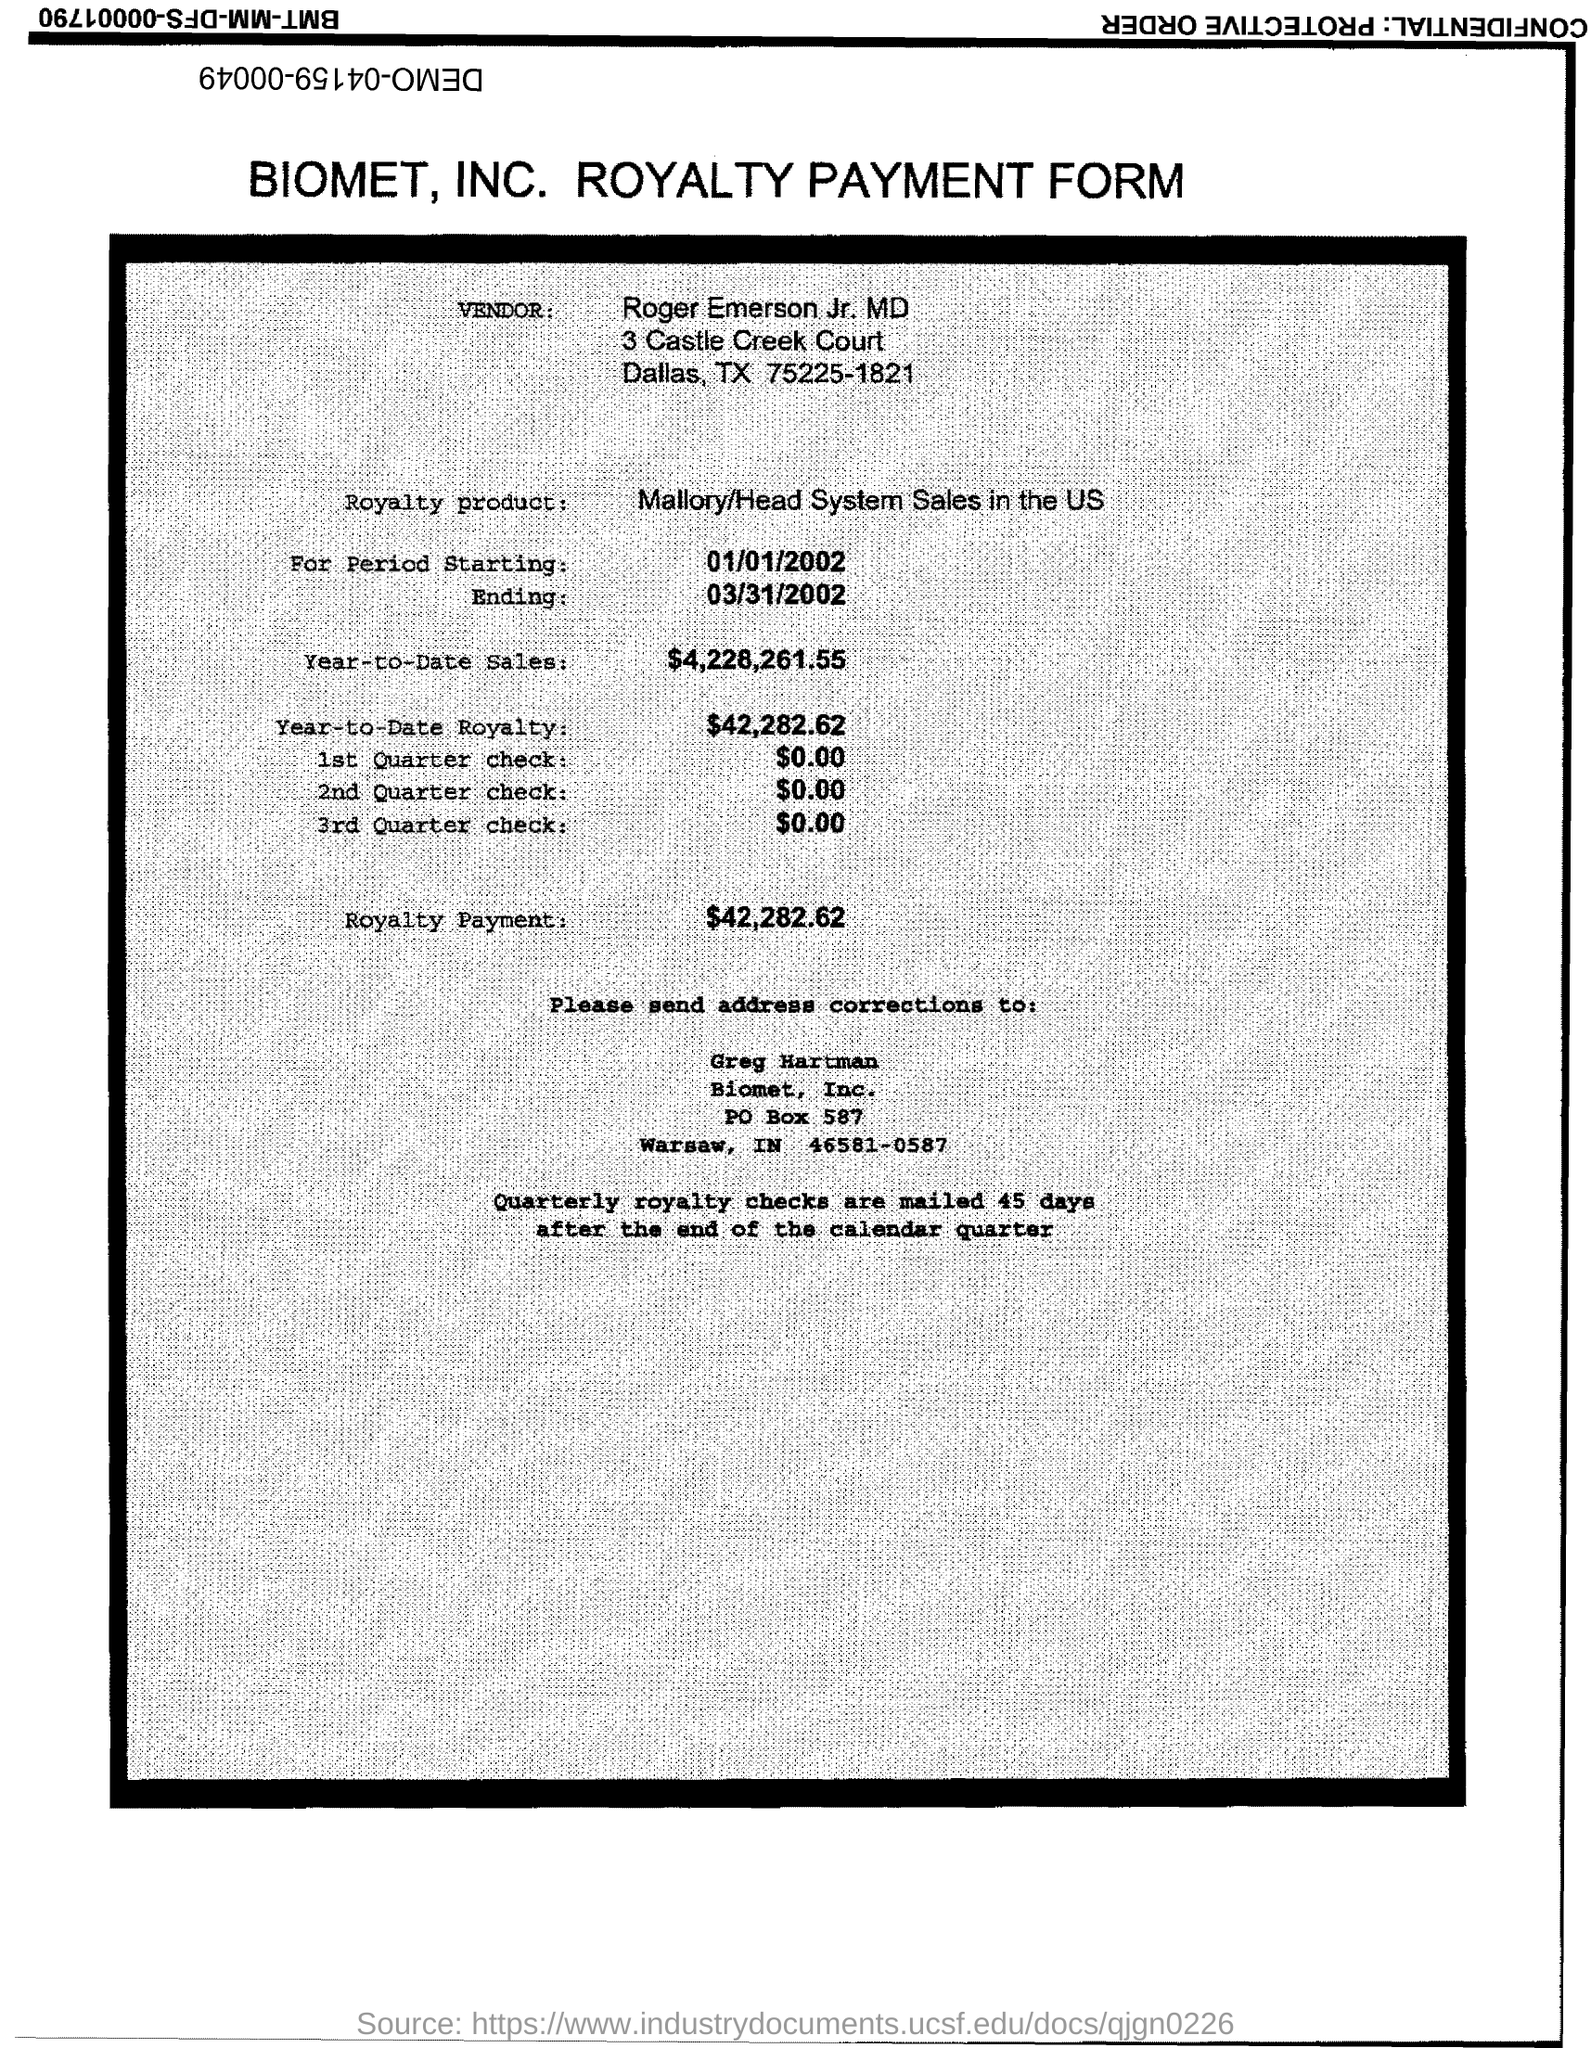Which company's royalty payment form is this?
Offer a very short reply. Biomet, Inc. What is the vendor name given in the form?
Provide a succinct answer. Roger Emerson Jr. MD. What is the royalty product given in the form?
Offer a very short reply. Mallory/Head System Sales in the US. What is the start date of the royalty period?
Offer a terse response. 01/01/2002. What is the Year-to-Date Sales of the royalty product?
Make the answer very short. $4,228,261.55. What is the Year-to-Date royalty of the product?
Offer a very short reply. $42,282.62. What is the amount of 1st quarter check mentioned in the form?
Keep it short and to the point. $0.00. What is the royalty payment of the product mentioned in the form?
Your answer should be compact. $42,282.62. What is the amount of 2nd Quarter check mentioned in the form?
Give a very brief answer. $0.00. 